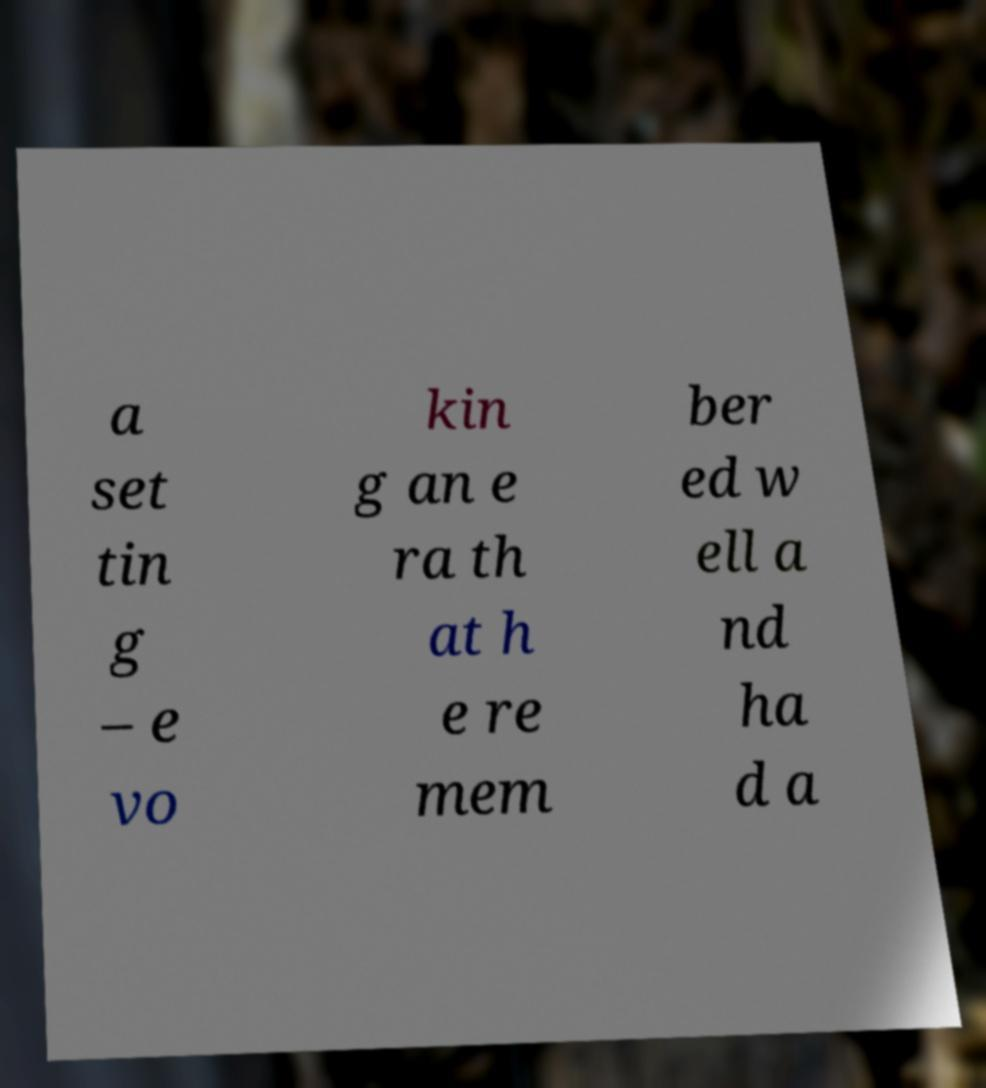There's text embedded in this image that I need extracted. Can you transcribe it verbatim? a set tin g – e vo kin g an e ra th at h e re mem ber ed w ell a nd ha d a 